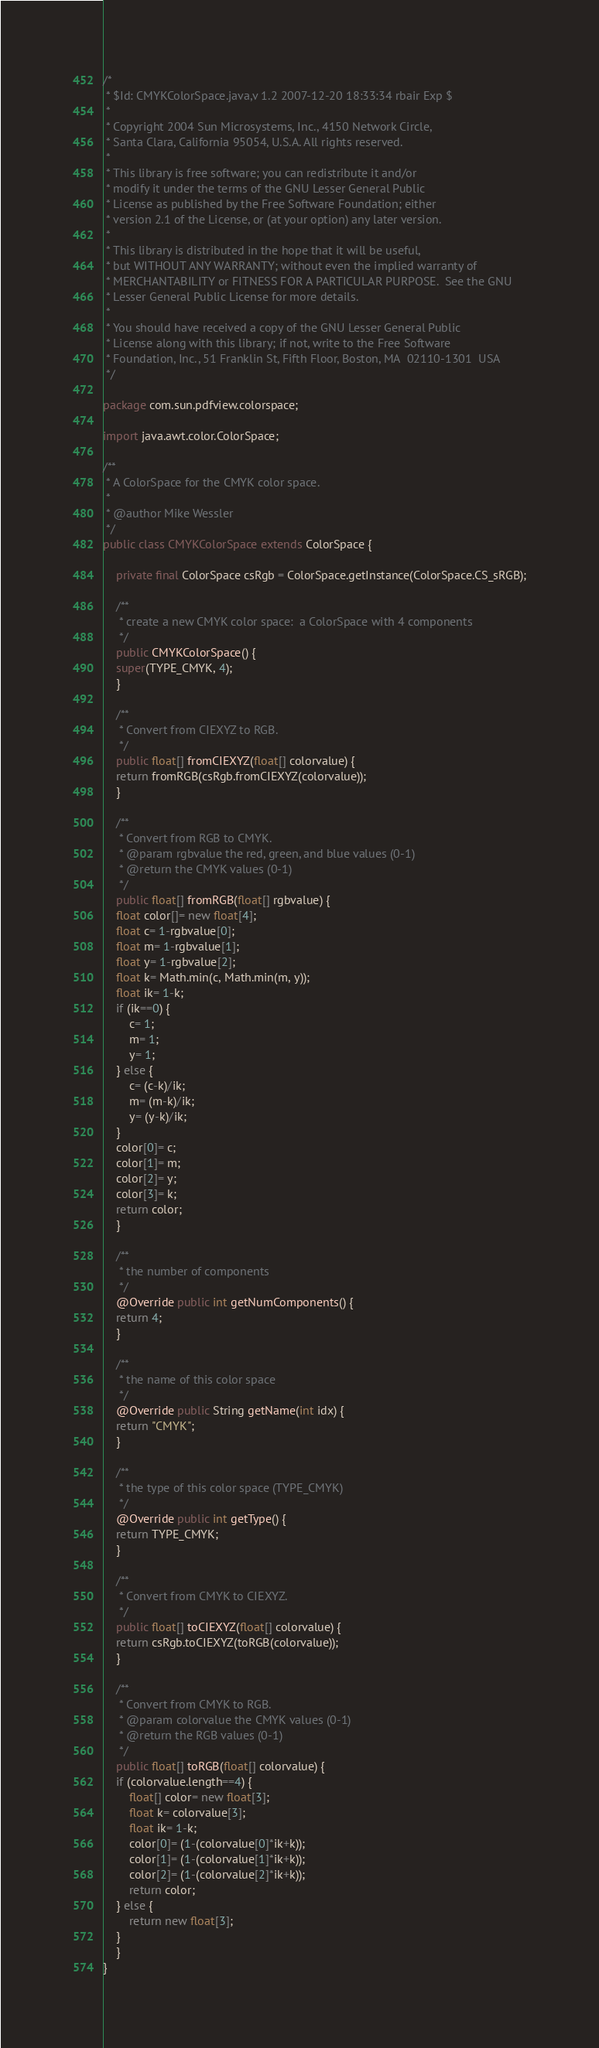Convert code to text. <code><loc_0><loc_0><loc_500><loc_500><_Java_>/*
 * $Id: CMYKColorSpace.java,v 1.2 2007-12-20 18:33:34 rbair Exp $
 *
 * Copyright 2004 Sun Microsystems, Inc., 4150 Network Circle,
 * Santa Clara, California 95054, U.S.A. All rights reserved.
 *
 * This library is free software; you can redistribute it and/or
 * modify it under the terms of the GNU Lesser General Public
 * License as published by the Free Software Foundation; either
 * version 2.1 of the License, or (at your option) any later version.
 * 
 * This library is distributed in the hope that it will be useful,
 * but WITHOUT ANY WARRANTY; without even the implied warranty of
 * MERCHANTABILITY or FITNESS FOR A PARTICULAR PURPOSE.  See the GNU
 * Lesser General Public License for more details.
 * 
 * You should have received a copy of the GNU Lesser General Public
 * License along with this library; if not, write to the Free Software
 * Foundation, Inc., 51 Franklin St, Fifth Floor, Boston, MA  02110-1301  USA
 */

package com.sun.pdfview.colorspace;

import java.awt.color.ColorSpace;

/**
 * A ColorSpace for the CMYK color space.
 *
 * @author Mike Wessler
 */
public class CMYKColorSpace extends ColorSpace {

    private final ColorSpace csRgb = ColorSpace.getInstance(ColorSpace.CS_sRGB);

    /**
     * create a new CMYK color space:  a ColorSpace with 4 components
     */
    public CMYKColorSpace() {
	super(TYPE_CMYK, 4);
    }

    /**
     * Convert from CIEXYZ to RGB.
     */    
    public float[] fromCIEXYZ(float[] colorvalue) {
	return fromRGB(csRgb.fromCIEXYZ(colorvalue));
    }

    /**
     * Convert from RGB to CMYK.
     * @param rgbvalue the red, green, and blue values (0-1)
     * @return the CMYK values (0-1)
     */
    public float[] fromRGB(float[] rgbvalue) {
	float color[]= new float[4];
	float c= 1-rgbvalue[0];
	float m= 1-rgbvalue[1];
	float y= 1-rgbvalue[2];
	float k= Math.min(c, Math.min(m, y));
	float ik= 1-k;
	if (ik==0) {
	    c= 1;
	    m= 1;
	    y= 1;
	} else {
	    c= (c-k)/ik;
	    m= (m-k)/ik;
	    y= (y-k)/ik;
	}
	color[0]= c;
	color[1]= m;
	color[2]= y;
	color[3]= k;
	return color;
    }

    /**
     * the number of components
     */
    @Override public int getNumComponents() {
	return 4;
    }

    /**
     * the name of this color space
     */
    @Override public String getName(int idx) {
	return "CMYK";
    }
    
    /**
     * the type of this color space (TYPE_CMYK)
     */
    @Override public int getType() {
	return TYPE_CMYK;
    }

    /**
     * Convert from CMYK to CIEXYZ.
     */
    public float[] toCIEXYZ(float[] colorvalue) {
	return csRgb.toCIEXYZ(toRGB(colorvalue));
    }

    /**
     * Convert from CMYK to RGB.
     * @param colorvalue the CMYK values (0-1)
     * @return the RGB values (0-1)
     */
    public float[] toRGB(float[] colorvalue) {
	if (colorvalue.length==4) {
	    float[] color= new float[3];
	    float k= colorvalue[3];
	    float ik= 1-k;
	    color[0]= (1-(colorvalue[0]*ik+k));
	    color[1]= (1-(colorvalue[1]*ik+k));
	    color[2]= (1-(colorvalue[2]*ik+k));
	    return color;
	} else {
	    return new float[3];
	}
    }
}
</code> 